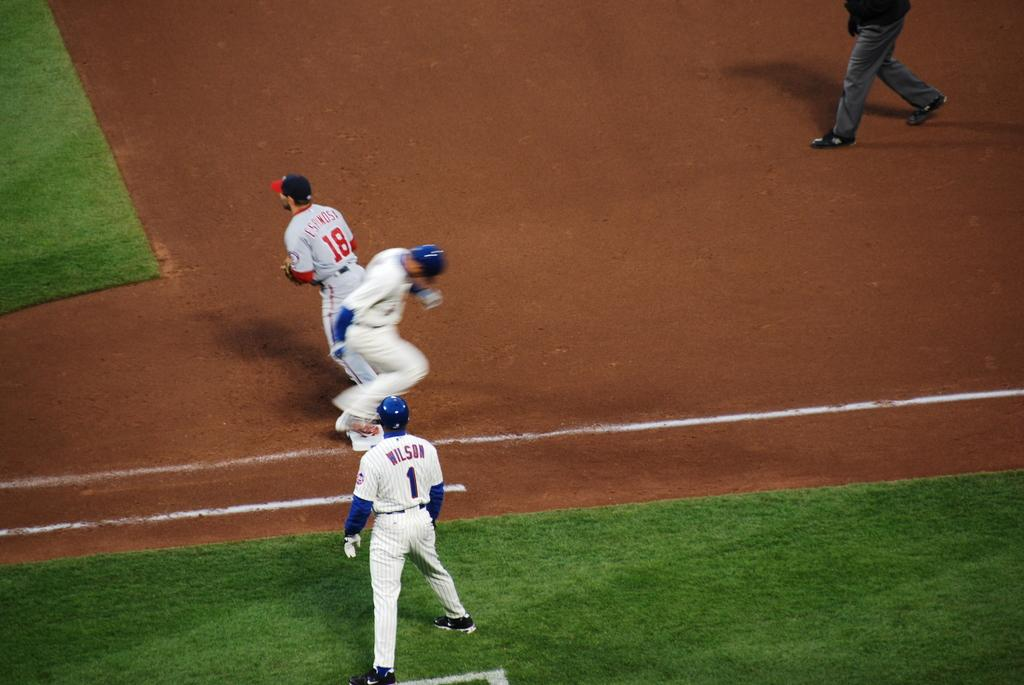<image>
Create a compact narrative representing the image presented. a player running to 1st base with a coach named Wilson next to them 